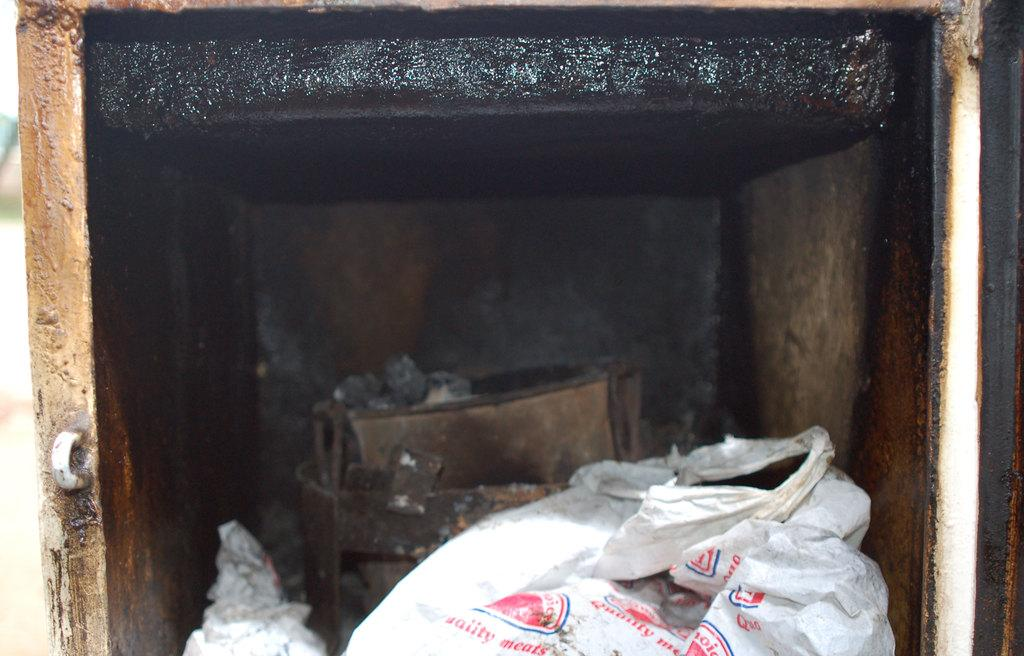What is present in the image that provides protection or concealment? There are covers in the image. What can be found inside the box in the image? There are other items in a box in the image. What type of war is being depicted in the image? There is no depiction of war in the image; it only features covers and a box with other items. What type of plastic is used to make the lunch containers in the image? There is no mention of lunch containers or plastic in the image; it only features covers and a box with other items. 